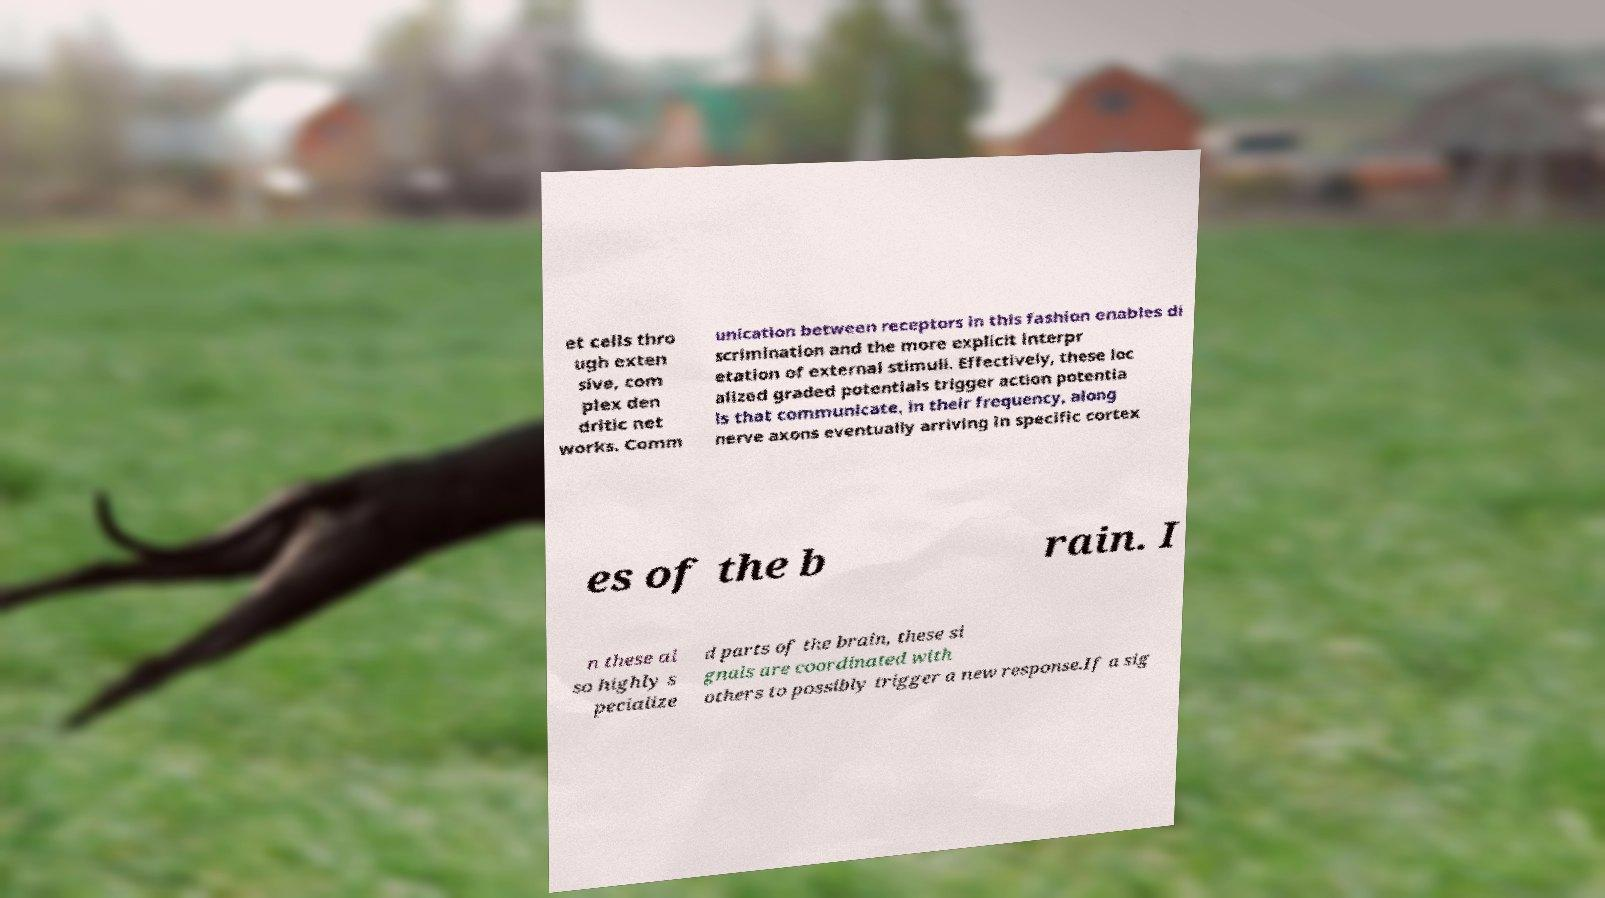What messages or text are displayed in this image? I need them in a readable, typed format. et cells thro ugh exten sive, com plex den dritic net works. Comm unication between receptors in this fashion enables di scrimination and the more explicit interpr etation of external stimuli. Effectively, these loc alized graded potentials trigger action potentia ls that communicate, in their frequency, along nerve axons eventually arriving in specific cortex es of the b rain. I n these al so highly s pecialize d parts of the brain, these si gnals are coordinated with others to possibly trigger a new response.If a sig 